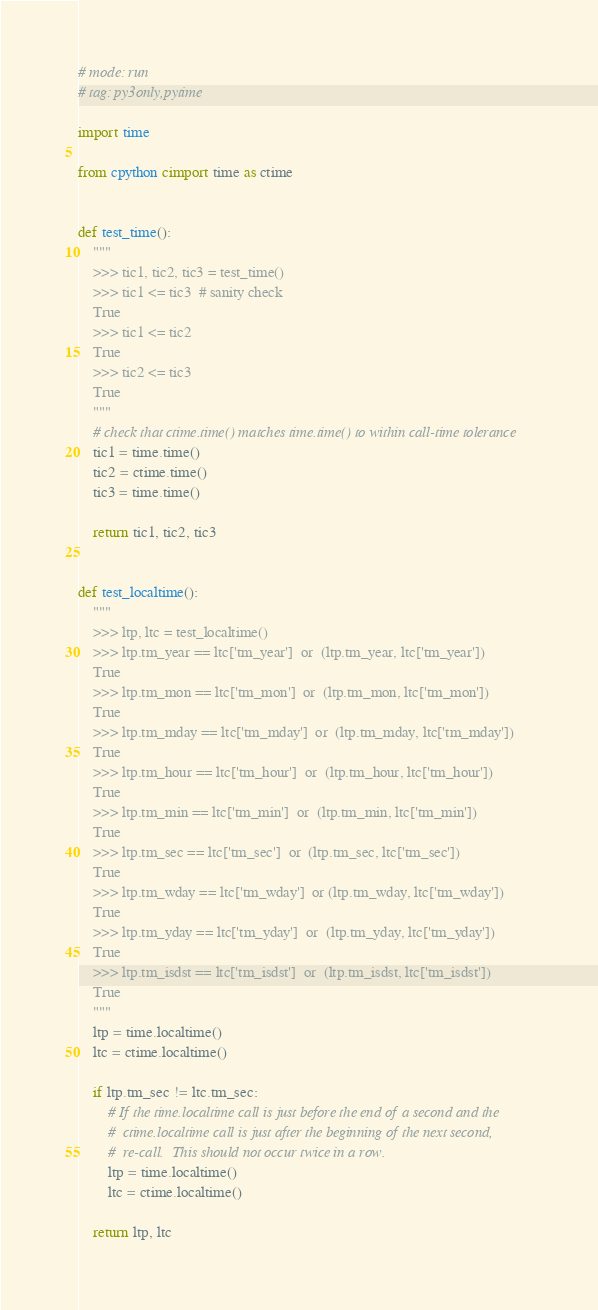<code> <loc_0><loc_0><loc_500><loc_500><_Cython_># mode: run
# tag: py3only,pytime

import time

from cpython cimport time as ctime


def test_time():
    """
    >>> tic1, tic2, tic3 = test_time()
    >>> tic1 <= tic3  # sanity check
    True
    >>> tic1 <= tic2
    True
    >>> tic2 <= tic3
    True
    """
    # check that ctime.time() matches time.time() to within call-time tolerance
    tic1 = time.time()
    tic2 = ctime.time()
    tic3 = time.time()

    return tic1, tic2, tic3


def test_localtime():
    """
    >>> ltp, ltc = test_localtime()
    >>> ltp.tm_year == ltc['tm_year']  or  (ltp.tm_year, ltc['tm_year'])
    True
    >>> ltp.tm_mon == ltc['tm_mon']  or  (ltp.tm_mon, ltc['tm_mon'])
    True
    >>> ltp.tm_mday == ltc['tm_mday']  or  (ltp.tm_mday, ltc['tm_mday'])
    True
    >>> ltp.tm_hour == ltc['tm_hour']  or  (ltp.tm_hour, ltc['tm_hour'])
    True
    >>> ltp.tm_min == ltc['tm_min']  or  (ltp.tm_min, ltc['tm_min'])
    True
    >>> ltp.tm_sec == ltc['tm_sec']  or  (ltp.tm_sec, ltc['tm_sec'])
    True
    >>> ltp.tm_wday == ltc['tm_wday']  or (ltp.tm_wday, ltc['tm_wday'])
    True
    >>> ltp.tm_yday == ltc['tm_yday']  or  (ltp.tm_yday, ltc['tm_yday'])
    True
    >>> ltp.tm_isdst == ltc['tm_isdst']  or  (ltp.tm_isdst, ltc['tm_isdst'])
    True
    """
    ltp = time.localtime()
    ltc = ctime.localtime()

    if ltp.tm_sec != ltc.tm_sec:
        # If the time.localtime call is just before the end of a second and the
        #  ctime.localtime call is just after the beginning of the next second,
        #  re-call.  This should not occur twice in a row.
        ltp = time.localtime()
        ltc = ctime.localtime()

    return ltp, ltc
</code> 